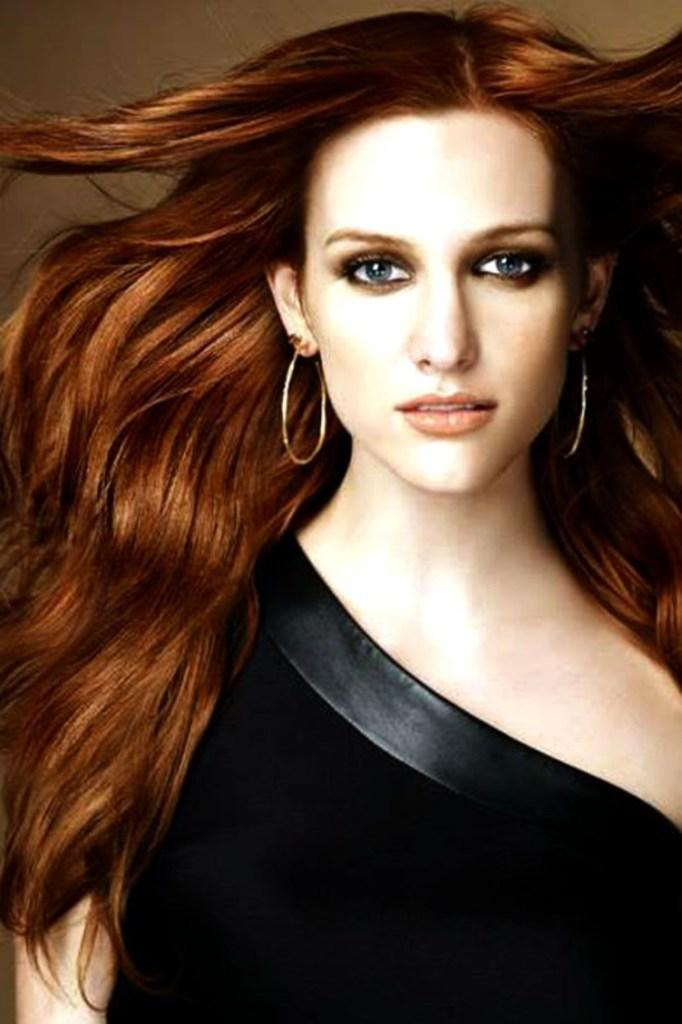Who is the main subject in the image? There is a woman in the image. What is the woman wearing? The woman is wearing a black dress. What color is the background of the image? The background of the image is brown. Is the woman sleeping in the image? There is no indication in the image that the woman is sleeping. Can you see any caves in the background of the image? There are no caves visible in the image; the background is brown. 